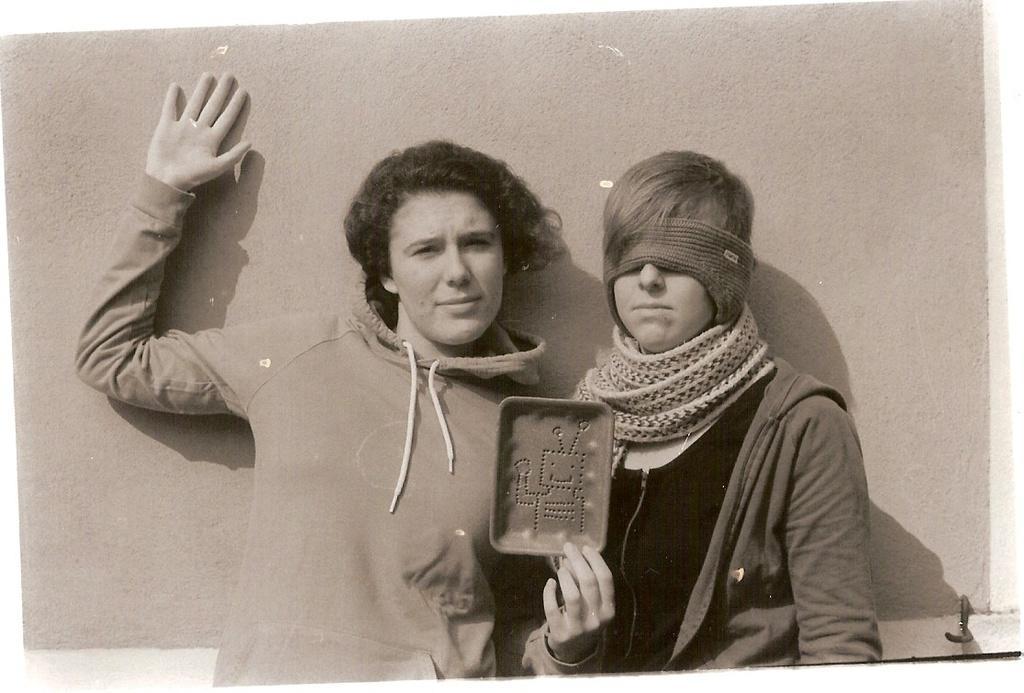Can you describe this image briefly? In this image there are two persons standing, one of them is holding an object in his hand and the other one is wearing a mask to his eyes. In the background there is a wall. 